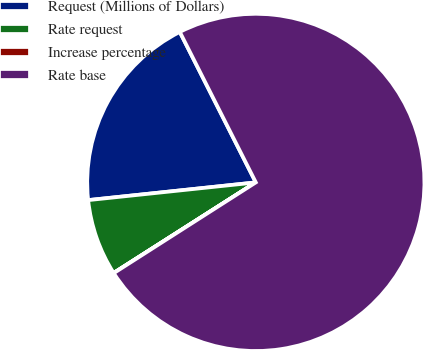Convert chart. <chart><loc_0><loc_0><loc_500><loc_500><pie_chart><fcel>Request (Millions of Dollars)<fcel>Rate request<fcel>Increase percentage<fcel>Rate base<nl><fcel>19.23%<fcel>7.35%<fcel>0.02%<fcel>73.4%<nl></chart> 